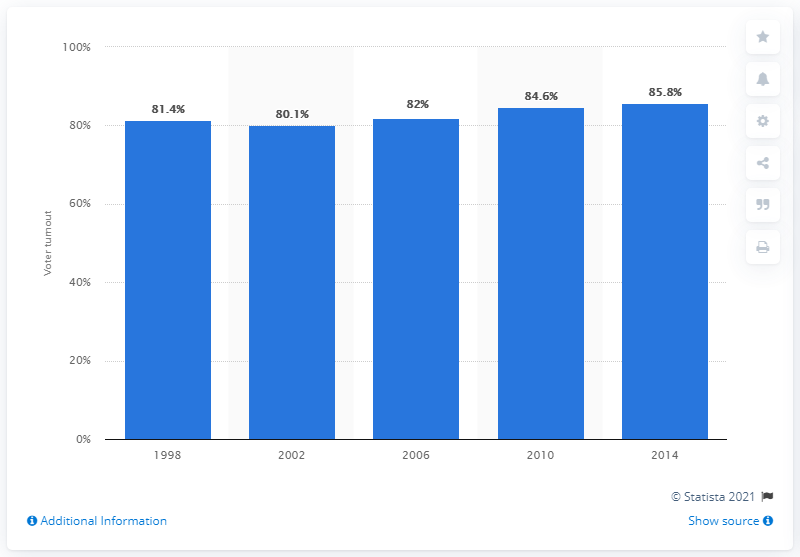List a handful of essential elements in this visual. In the most recent parliamentary election in Sweden, 85.8% of eligible voters cast their ballots. 